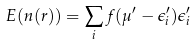<formula> <loc_0><loc_0><loc_500><loc_500>E ( n ( r ) ) = \sum _ { i } f ( \mu ^ { \prime } - \epsilon ^ { \prime } _ { i } ) \epsilon ^ { \prime } _ { i }</formula> 